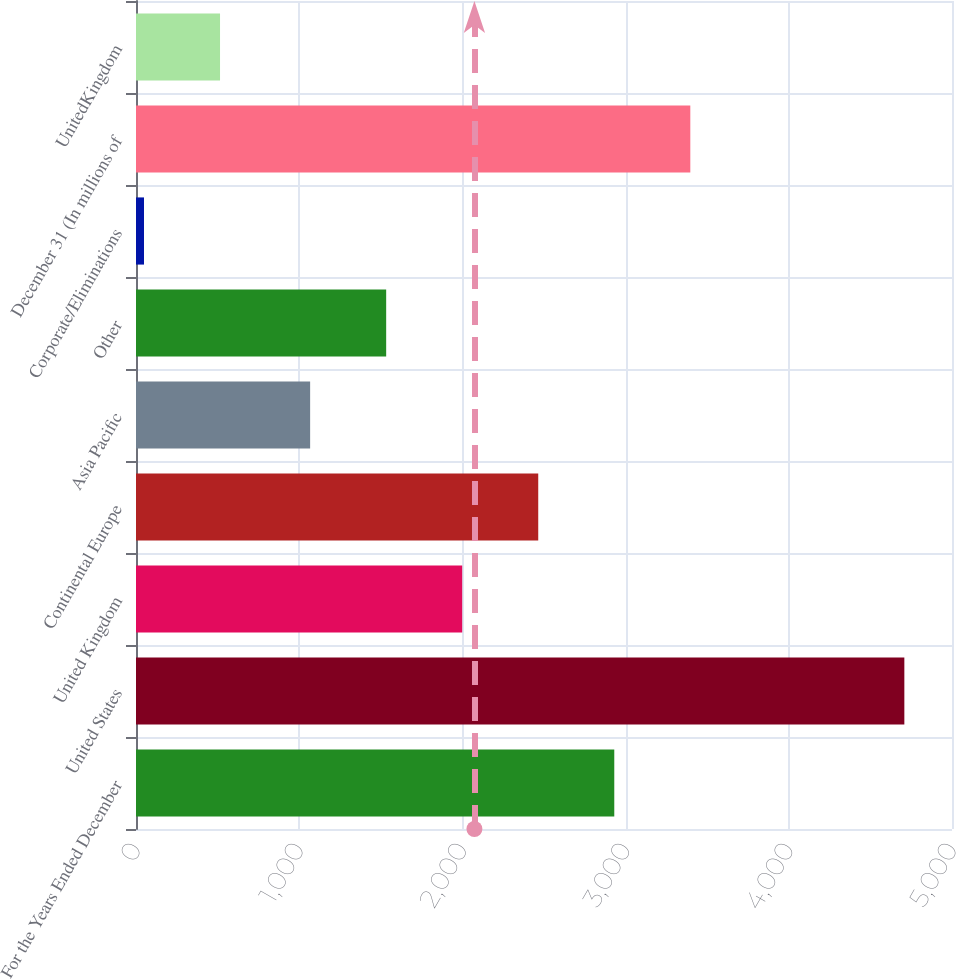Convert chart. <chart><loc_0><loc_0><loc_500><loc_500><bar_chart><fcel>For the Years Ended December<fcel>United States<fcel>United Kingdom<fcel>Continental Europe<fcel>Asia Pacific<fcel>Other<fcel>Corporate/Eliminations<fcel>December 31 (In millions of<fcel>UnitedKingdom<nl><fcel>2930.6<fcel>4708<fcel>1998.8<fcel>2464.7<fcel>1067<fcel>1532.9<fcel>49<fcel>3396.5<fcel>514.9<nl></chart> 